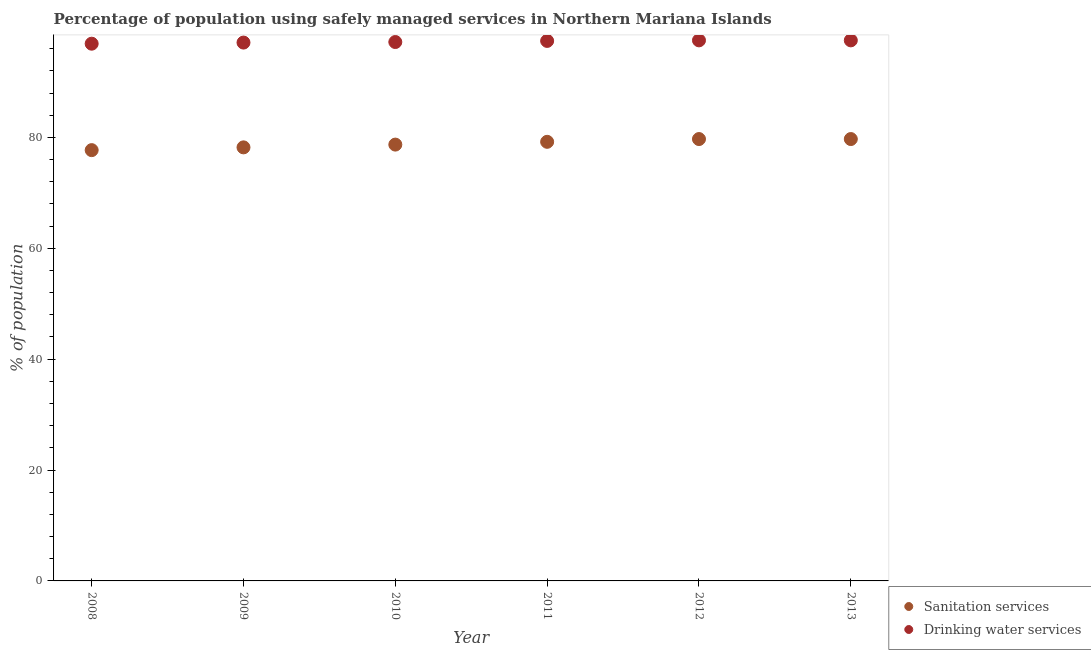What is the percentage of population who used drinking water services in 2010?
Keep it short and to the point. 97.2. Across all years, what is the maximum percentage of population who used sanitation services?
Ensure brevity in your answer.  79.7. Across all years, what is the minimum percentage of population who used drinking water services?
Give a very brief answer. 96.9. In which year was the percentage of population who used drinking water services maximum?
Offer a terse response. 2012. What is the total percentage of population who used drinking water services in the graph?
Your answer should be compact. 583.6. What is the difference between the percentage of population who used sanitation services in 2011 and that in 2013?
Ensure brevity in your answer.  -0.5. What is the difference between the percentage of population who used sanitation services in 2013 and the percentage of population who used drinking water services in 2008?
Provide a short and direct response. -17.2. What is the average percentage of population who used sanitation services per year?
Your answer should be compact. 78.87. In the year 2009, what is the difference between the percentage of population who used sanitation services and percentage of population who used drinking water services?
Provide a short and direct response. -18.9. What is the ratio of the percentage of population who used drinking water services in 2010 to that in 2012?
Make the answer very short. 1. Is the difference between the percentage of population who used drinking water services in 2009 and 2012 greater than the difference between the percentage of population who used sanitation services in 2009 and 2012?
Give a very brief answer. Yes. What is the difference between the highest and the lowest percentage of population who used sanitation services?
Offer a terse response. 2. In how many years, is the percentage of population who used sanitation services greater than the average percentage of population who used sanitation services taken over all years?
Give a very brief answer. 3. Is the sum of the percentage of population who used sanitation services in 2010 and 2013 greater than the maximum percentage of population who used drinking water services across all years?
Make the answer very short. Yes. Does the percentage of population who used sanitation services monotonically increase over the years?
Provide a short and direct response. No. Is the percentage of population who used drinking water services strictly greater than the percentage of population who used sanitation services over the years?
Your response must be concise. Yes. How many years are there in the graph?
Your answer should be compact. 6. What is the difference between two consecutive major ticks on the Y-axis?
Offer a very short reply. 20. Are the values on the major ticks of Y-axis written in scientific E-notation?
Your answer should be compact. No. Does the graph contain any zero values?
Give a very brief answer. No. Does the graph contain grids?
Provide a short and direct response. No. Where does the legend appear in the graph?
Offer a very short reply. Bottom right. How are the legend labels stacked?
Your answer should be very brief. Vertical. What is the title of the graph?
Provide a short and direct response. Percentage of population using safely managed services in Northern Mariana Islands. Does "Primary" appear as one of the legend labels in the graph?
Keep it short and to the point. No. What is the label or title of the Y-axis?
Provide a short and direct response. % of population. What is the % of population of Sanitation services in 2008?
Provide a succinct answer. 77.7. What is the % of population of Drinking water services in 2008?
Your response must be concise. 96.9. What is the % of population in Sanitation services in 2009?
Your answer should be very brief. 78.2. What is the % of population of Drinking water services in 2009?
Offer a very short reply. 97.1. What is the % of population in Sanitation services in 2010?
Your answer should be very brief. 78.7. What is the % of population of Drinking water services in 2010?
Offer a terse response. 97.2. What is the % of population of Sanitation services in 2011?
Keep it short and to the point. 79.2. What is the % of population of Drinking water services in 2011?
Your answer should be compact. 97.4. What is the % of population of Sanitation services in 2012?
Provide a short and direct response. 79.7. What is the % of population in Drinking water services in 2012?
Give a very brief answer. 97.5. What is the % of population in Sanitation services in 2013?
Keep it short and to the point. 79.7. What is the % of population of Drinking water services in 2013?
Your answer should be compact. 97.5. Across all years, what is the maximum % of population of Sanitation services?
Ensure brevity in your answer.  79.7. Across all years, what is the maximum % of population of Drinking water services?
Provide a succinct answer. 97.5. Across all years, what is the minimum % of population in Sanitation services?
Make the answer very short. 77.7. Across all years, what is the minimum % of population in Drinking water services?
Provide a succinct answer. 96.9. What is the total % of population in Sanitation services in the graph?
Give a very brief answer. 473.2. What is the total % of population in Drinking water services in the graph?
Keep it short and to the point. 583.6. What is the difference between the % of population in Sanitation services in 2008 and that in 2009?
Keep it short and to the point. -0.5. What is the difference between the % of population in Drinking water services in 2008 and that in 2009?
Provide a short and direct response. -0.2. What is the difference between the % of population in Sanitation services in 2008 and that in 2010?
Make the answer very short. -1. What is the difference between the % of population in Drinking water services in 2008 and that in 2010?
Make the answer very short. -0.3. What is the difference between the % of population in Drinking water services in 2008 and that in 2011?
Ensure brevity in your answer.  -0.5. What is the difference between the % of population of Drinking water services in 2008 and that in 2012?
Make the answer very short. -0.6. What is the difference between the % of population of Drinking water services in 2008 and that in 2013?
Ensure brevity in your answer.  -0.6. What is the difference between the % of population in Sanitation services in 2009 and that in 2010?
Your answer should be compact. -0.5. What is the difference between the % of population in Sanitation services in 2009 and that in 2012?
Keep it short and to the point. -1.5. What is the difference between the % of population of Drinking water services in 2009 and that in 2013?
Give a very brief answer. -0.4. What is the difference between the % of population in Drinking water services in 2010 and that in 2011?
Offer a terse response. -0.2. What is the difference between the % of population of Sanitation services in 2010 and that in 2012?
Make the answer very short. -1. What is the difference between the % of population of Drinking water services in 2010 and that in 2012?
Offer a terse response. -0.3. What is the difference between the % of population in Sanitation services in 2010 and that in 2013?
Ensure brevity in your answer.  -1. What is the difference between the % of population in Drinking water services in 2010 and that in 2013?
Your answer should be very brief. -0.3. What is the difference between the % of population in Sanitation services in 2011 and that in 2012?
Offer a very short reply. -0.5. What is the difference between the % of population of Drinking water services in 2011 and that in 2012?
Keep it short and to the point. -0.1. What is the difference between the % of population in Drinking water services in 2012 and that in 2013?
Your answer should be compact. 0. What is the difference between the % of population of Sanitation services in 2008 and the % of population of Drinking water services in 2009?
Keep it short and to the point. -19.4. What is the difference between the % of population of Sanitation services in 2008 and the % of population of Drinking water services in 2010?
Provide a short and direct response. -19.5. What is the difference between the % of population in Sanitation services in 2008 and the % of population in Drinking water services in 2011?
Your response must be concise. -19.7. What is the difference between the % of population of Sanitation services in 2008 and the % of population of Drinking water services in 2012?
Make the answer very short. -19.8. What is the difference between the % of population of Sanitation services in 2008 and the % of population of Drinking water services in 2013?
Your answer should be compact. -19.8. What is the difference between the % of population in Sanitation services in 2009 and the % of population in Drinking water services in 2011?
Provide a succinct answer. -19.2. What is the difference between the % of population in Sanitation services in 2009 and the % of population in Drinking water services in 2012?
Your response must be concise. -19.3. What is the difference between the % of population of Sanitation services in 2009 and the % of population of Drinking water services in 2013?
Keep it short and to the point. -19.3. What is the difference between the % of population of Sanitation services in 2010 and the % of population of Drinking water services in 2011?
Provide a succinct answer. -18.7. What is the difference between the % of population in Sanitation services in 2010 and the % of population in Drinking water services in 2012?
Ensure brevity in your answer.  -18.8. What is the difference between the % of population in Sanitation services in 2010 and the % of population in Drinking water services in 2013?
Give a very brief answer. -18.8. What is the difference between the % of population in Sanitation services in 2011 and the % of population in Drinking water services in 2012?
Provide a succinct answer. -18.3. What is the difference between the % of population of Sanitation services in 2011 and the % of population of Drinking water services in 2013?
Provide a short and direct response. -18.3. What is the difference between the % of population of Sanitation services in 2012 and the % of population of Drinking water services in 2013?
Provide a succinct answer. -17.8. What is the average % of population of Sanitation services per year?
Your answer should be compact. 78.87. What is the average % of population of Drinking water services per year?
Keep it short and to the point. 97.27. In the year 2008, what is the difference between the % of population of Sanitation services and % of population of Drinking water services?
Make the answer very short. -19.2. In the year 2009, what is the difference between the % of population in Sanitation services and % of population in Drinking water services?
Offer a very short reply. -18.9. In the year 2010, what is the difference between the % of population of Sanitation services and % of population of Drinking water services?
Your answer should be very brief. -18.5. In the year 2011, what is the difference between the % of population in Sanitation services and % of population in Drinking water services?
Offer a terse response. -18.2. In the year 2012, what is the difference between the % of population of Sanitation services and % of population of Drinking water services?
Give a very brief answer. -17.8. In the year 2013, what is the difference between the % of population in Sanitation services and % of population in Drinking water services?
Your answer should be compact. -17.8. What is the ratio of the % of population in Drinking water services in 2008 to that in 2009?
Provide a short and direct response. 1. What is the ratio of the % of population of Sanitation services in 2008 to that in 2010?
Make the answer very short. 0.99. What is the ratio of the % of population in Sanitation services in 2008 to that in 2011?
Make the answer very short. 0.98. What is the ratio of the % of population of Sanitation services in 2008 to that in 2012?
Keep it short and to the point. 0.97. What is the ratio of the % of population of Drinking water services in 2008 to that in 2012?
Keep it short and to the point. 0.99. What is the ratio of the % of population in Sanitation services in 2008 to that in 2013?
Offer a very short reply. 0.97. What is the ratio of the % of population in Drinking water services in 2008 to that in 2013?
Offer a terse response. 0.99. What is the ratio of the % of population of Sanitation services in 2009 to that in 2011?
Ensure brevity in your answer.  0.99. What is the ratio of the % of population in Drinking water services in 2009 to that in 2011?
Give a very brief answer. 1. What is the ratio of the % of population in Sanitation services in 2009 to that in 2012?
Your answer should be compact. 0.98. What is the ratio of the % of population in Drinking water services in 2009 to that in 2012?
Give a very brief answer. 1. What is the ratio of the % of population of Sanitation services in 2009 to that in 2013?
Make the answer very short. 0.98. What is the ratio of the % of population of Sanitation services in 2010 to that in 2011?
Ensure brevity in your answer.  0.99. What is the ratio of the % of population of Drinking water services in 2010 to that in 2011?
Your response must be concise. 1. What is the ratio of the % of population in Sanitation services in 2010 to that in 2012?
Your answer should be very brief. 0.99. What is the ratio of the % of population of Sanitation services in 2010 to that in 2013?
Keep it short and to the point. 0.99. What is the ratio of the % of population of Drinking water services in 2010 to that in 2013?
Your response must be concise. 1. What is the ratio of the % of population in Sanitation services in 2011 to that in 2012?
Give a very brief answer. 0.99. What is the ratio of the % of population of Drinking water services in 2011 to that in 2012?
Your answer should be very brief. 1. What is the ratio of the % of population of Sanitation services in 2011 to that in 2013?
Offer a terse response. 0.99. What is the ratio of the % of population of Drinking water services in 2012 to that in 2013?
Give a very brief answer. 1. What is the difference between the highest and the second highest % of population in Drinking water services?
Your response must be concise. 0. What is the difference between the highest and the lowest % of population of Sanitation services?
Make the answer very short. 2. What is the difference between the highest and the lowest % of population in Drinking water services?
Make the answer very short. 0.6. 